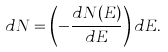Convert formula to latex. <formula><loc_0><loc_0><loc_500><loc_500>d N = \left ( - \frac { d N ( E ) } { d E } \right ) d E .</formula> 